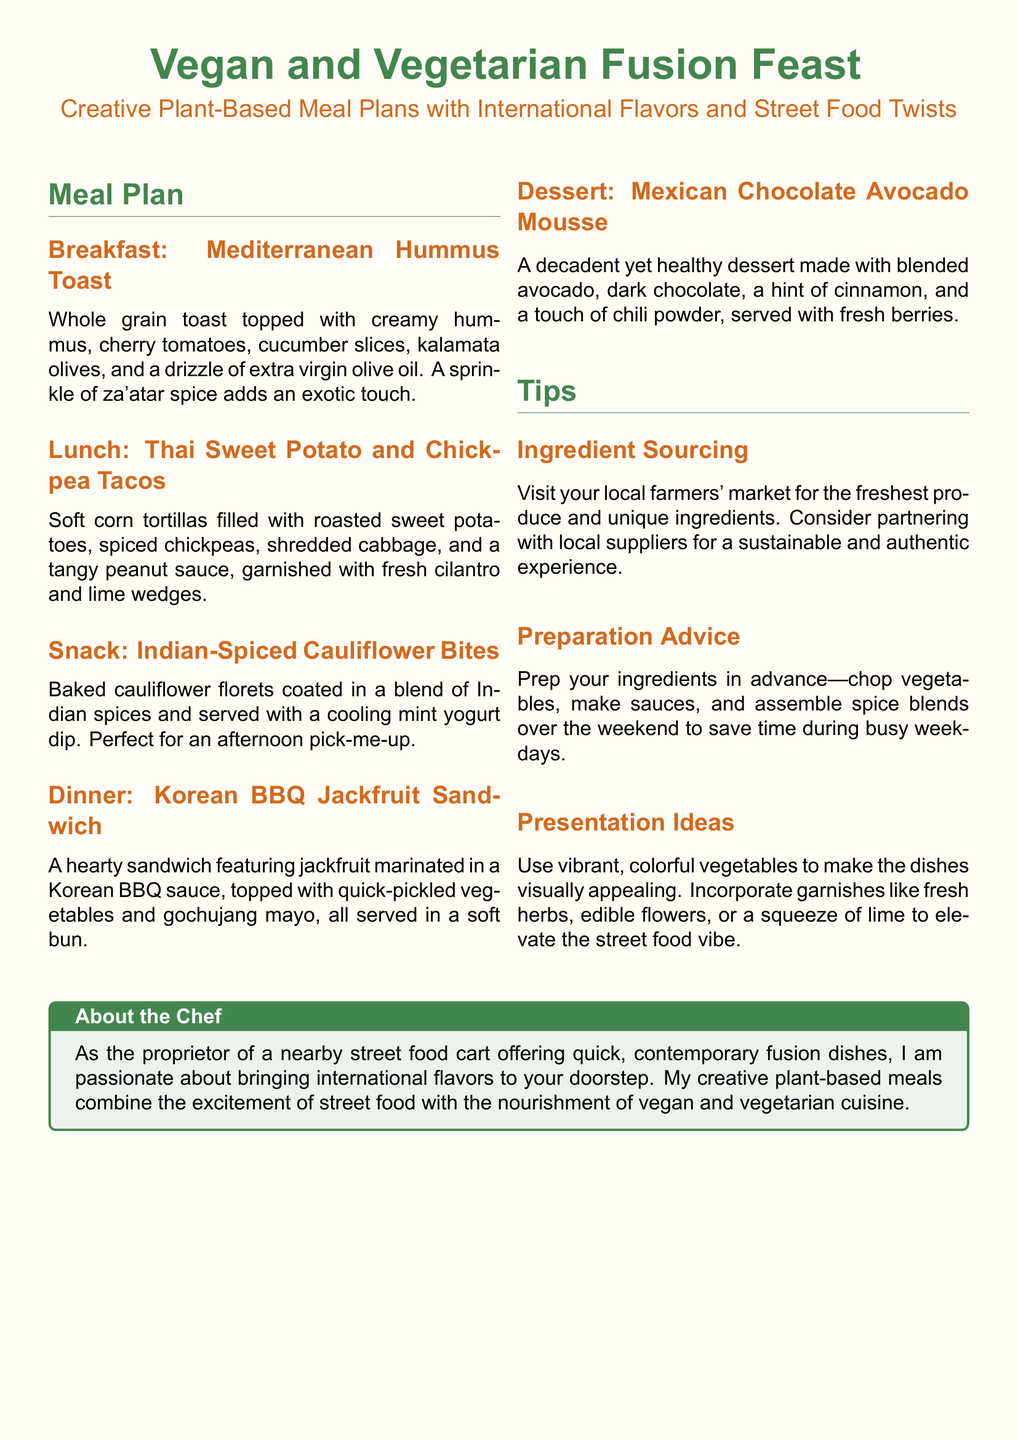What is the breakfast dish? The breakfast dish is listed in the meal plan as Mediterranean Hummus Toast.
Answer: Mediterranean Hummus Toast What is used as a dip for the Indian-Spiced Cauliflower Bites? The dip available for the Indian-Spiced Cauliflower Bites is a cooling mint yogurt dip.
Answer: cooling mint yogurt dip What type of tortillas are used in the lunch dish? The tortillas mentioned for the Thai Sweet Potato and Chickpea Tacos are soft corn tortillas.
Answer: soft corn tortillas What key ingredient is primarily featured in the dinner dish? The key ingredient in the Korean BBQ Jackfruit Sandwich is jackfruit marinated in BBQ sauce.
Answer: jackfruit What chocolate is used in the dessert? The dessert features dark chocolate blended with avocado.
Answer: dark chocolate What spice is recommended to enhance the breakfast dish? The spice suggested to enhance the Mediterranean Hummus Toast is za'atar spice.
Answer: za'atar spice How should you prepare ingredients for the meals? The preparation advice suggests you should prep ingredients in advance by chopping vegetables and making sauces.
Answer: prep ingredients in advance What unique feature is mentioned about ingredient sourcing? The document highlights that you should visit local farmers' markets for fresh produce.
Answer: local farmers' markets How can dishes be visually enhanced according to the presentation ideas? To enhance dishes visually, the document advises using vibrant, colorful vegetables.
Answer: vibrant, colorful vegetables 